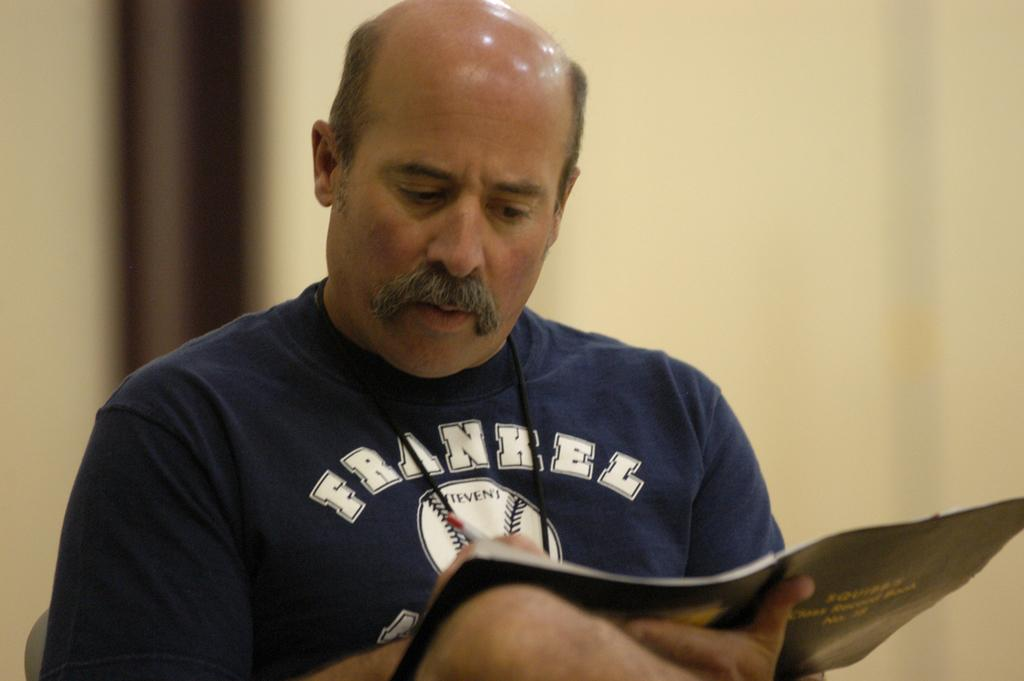<image>
Provide a brief description of the given image. A man wearing a Frankel softball shirt is writing something. 